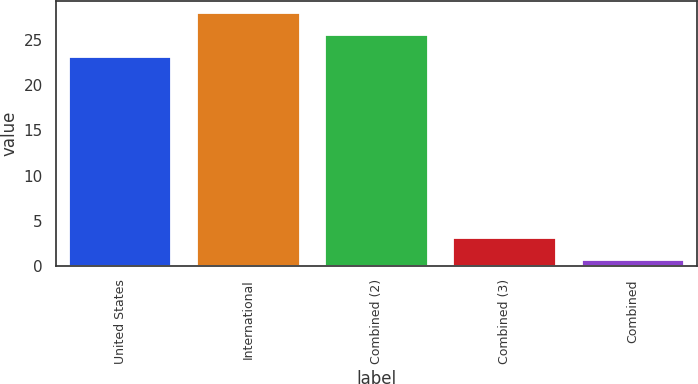Convert chart to OTSL. <chart><loc_0><loc_0><loc_500><loc_500><bar_chart><fcel>United States<fcel>International<fcel>Combined (2)<fcel>Combined (3)<fcel>Combined<nl><fcel>23.08<fcel>27.94<fcel>25.51<fcel>3.13<fcel>0.7<nl></chart> 